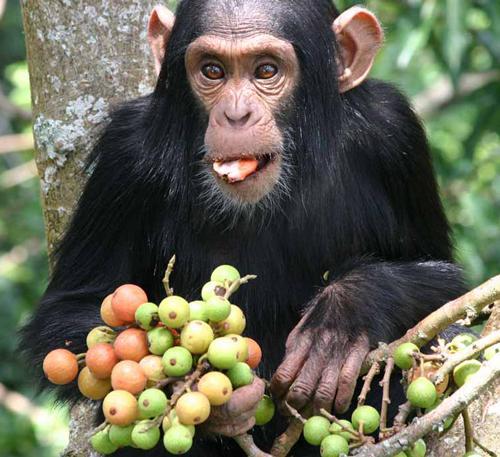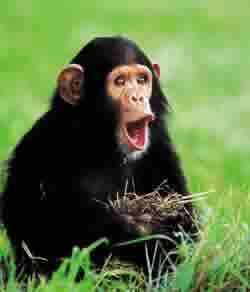The first image is the image on the left, the second image is the image on the right. Considering the images on both sides, is "In one image a chimp is making an O shape with their mouth" valid? Answer yes or no. Yes. 